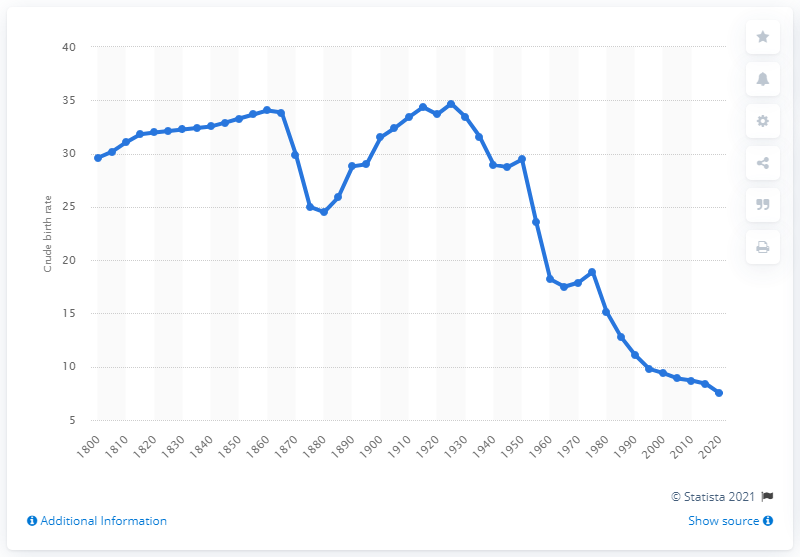Point out several critical features in this image. According to projections, Japan's crude birth rate is expected to be approximately 7.5 births per thousand people in 2020. 